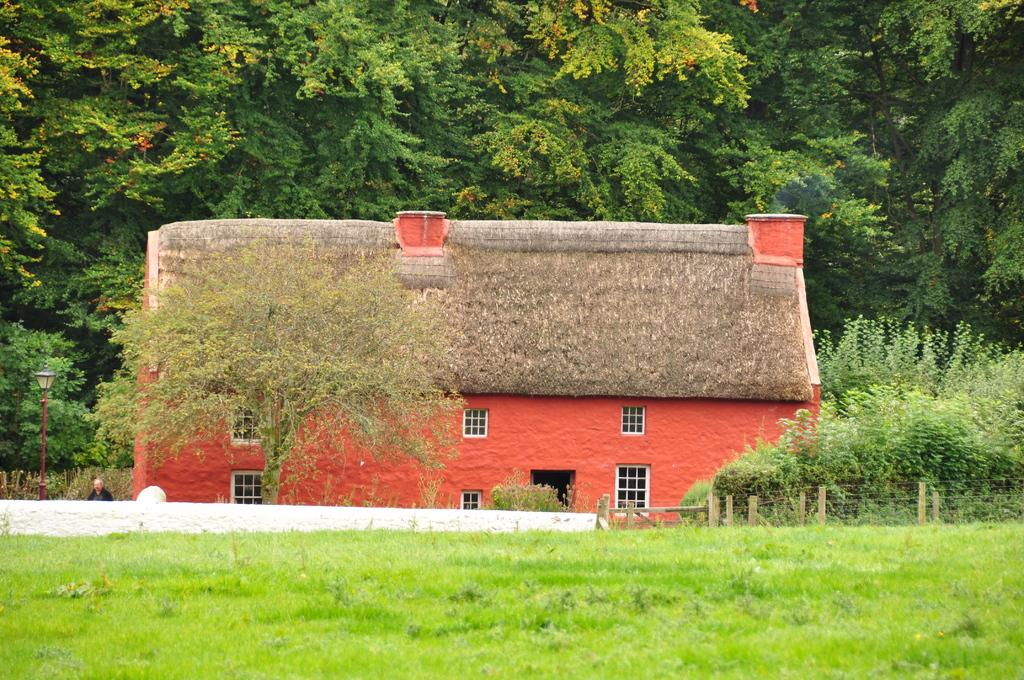What type of structure is visible in the image? There is a house in the image. What can be seen in the background of the image? There are trees in the image. What is the purpose of the fence in the image? The fence is likely used to mark boundaries or provide privacy. How many windows are visible in the image? There are windows in the image. What type of ground covering is present in the image? There is grass on the ground in the image. Can you describe the person in the image? There is a person in the image, but no specific details about their appearance or actions are provided. What is the purpose of the pole with a light on it in the image? The pole with a light on it is likely used for illumination, such as a street light or porch light. What type of tent is set up in the image? There is no tent present in the image. How many sides does the square house have in the image? The house in the image is not described as a square, so it is not possible to determine the number of sides it has. 